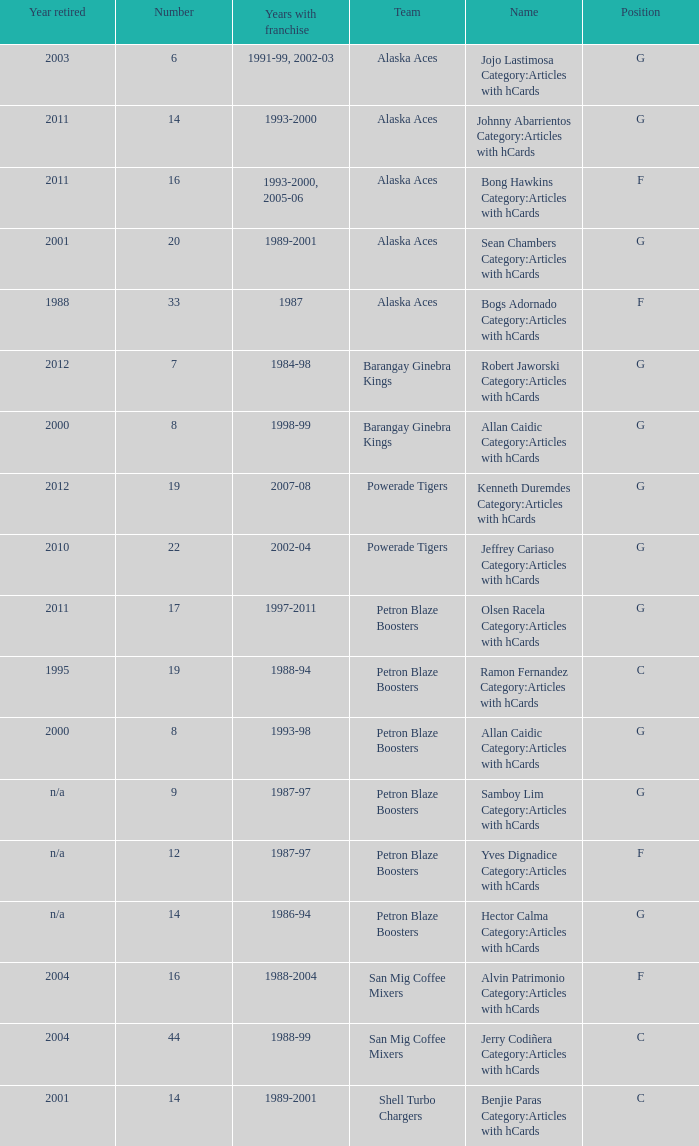How many years did the team in slot number 9 have a franchise? 1987-97. 